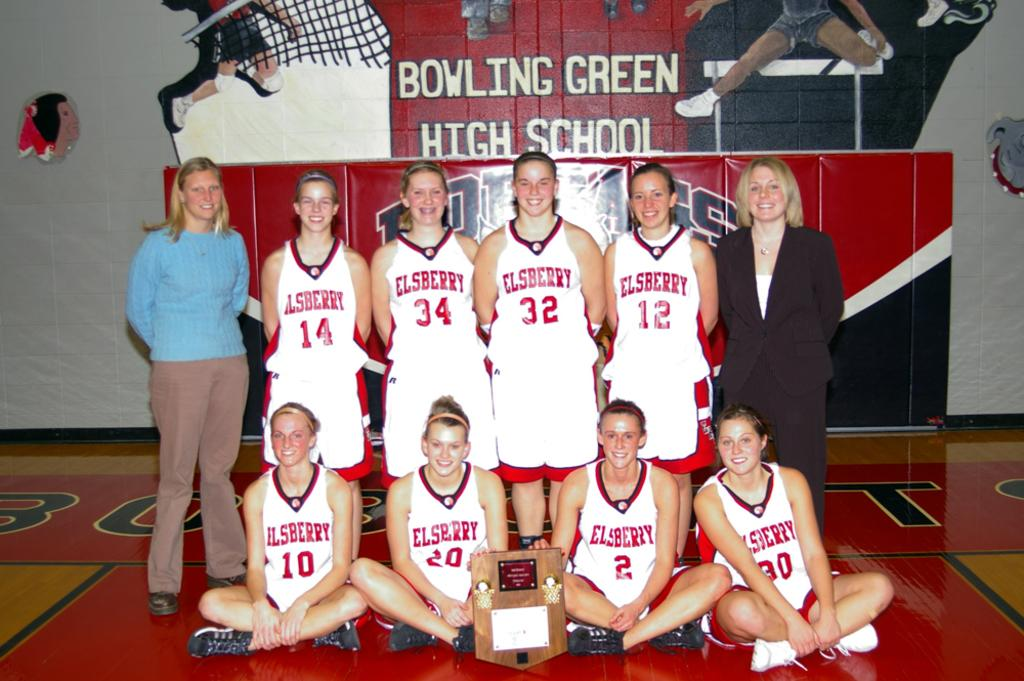<image>
Offer a succinct explanation of the picture presented. A Elsberry basketball team posing for a team photo 